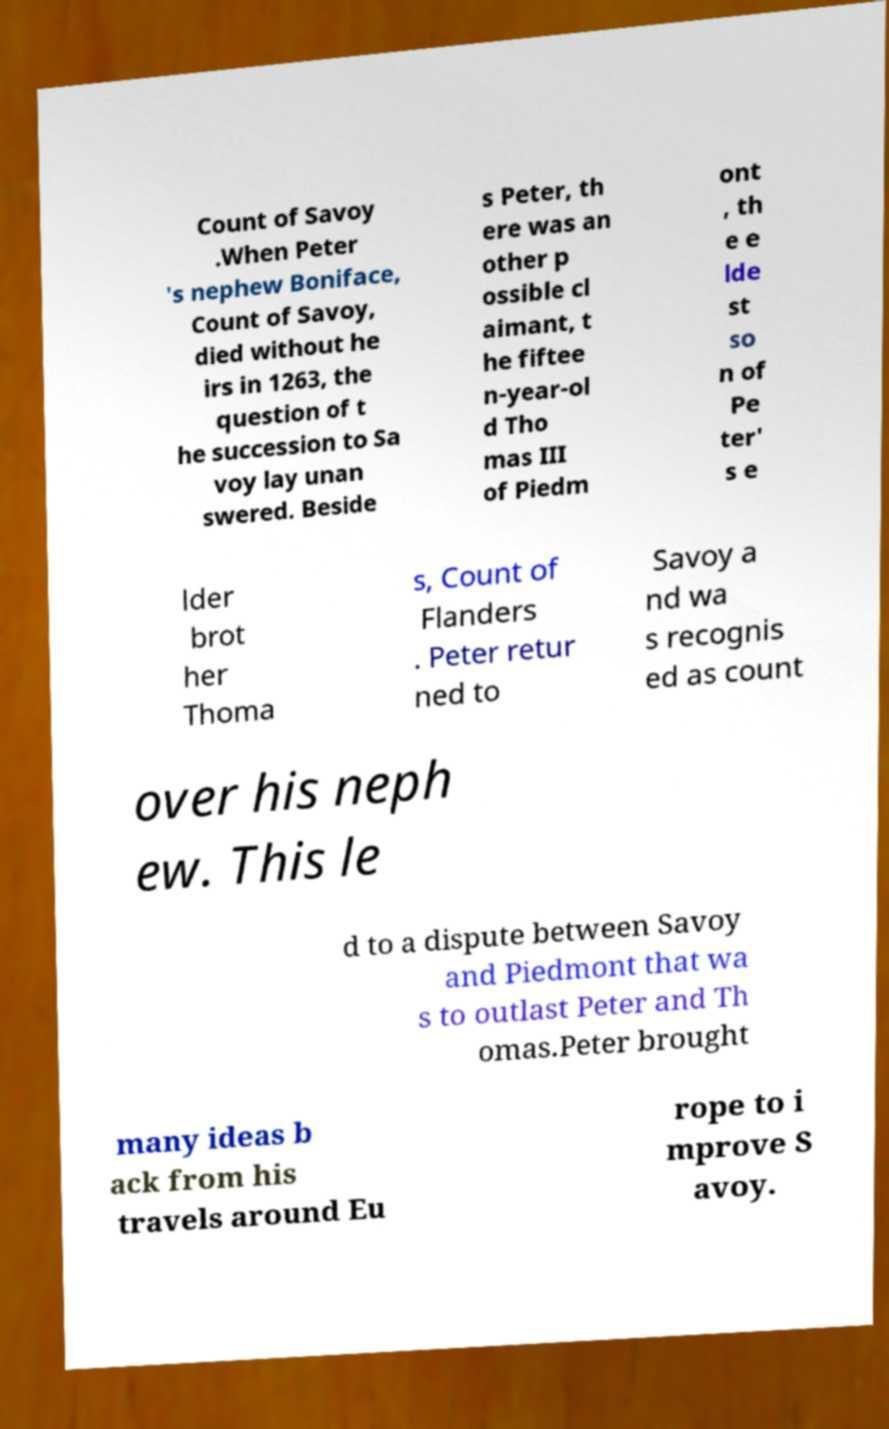Please identify and transcribe the text found in this image. Count of Savoy .When Peter 's nephew Boniface, Count of Savoy, died without he irs in 1263, the question of t he succession to Sa voy lay unan swered. Beside s Peter, th ere was an other p ossible cl aimant, t he fiftee n-year-ol d Tho mas III of Piedm ont , th e e lde st so n of Pe ter' s e lder brot her Thoma s, Count of Flanders . Peter retur ned to Savoy a nd wa s recognis ed as count over his neph ew. This le d to a dispute between Savoy and Piedmont that wa s to outlast Peter and Th omas.Peter brought many ideas b ack from his travels around Eu rope to i mprove S avoy. 